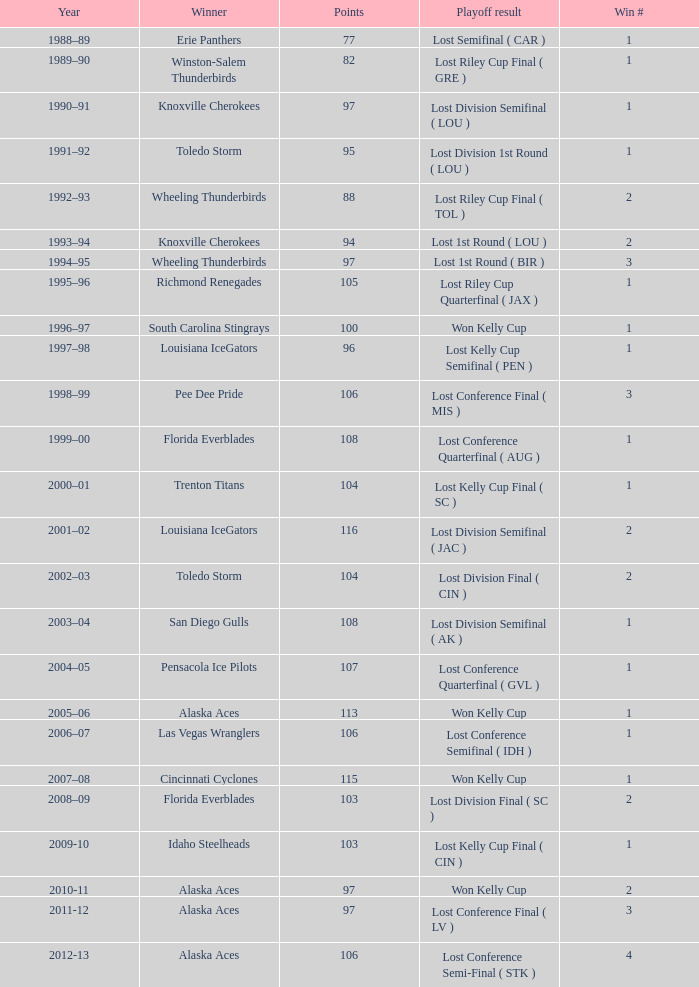What is the maximum win count, when the winner is "knoxville cherokees", when playoff outcome is "lost 1st round ( lou )", and when points are below 94? None. 